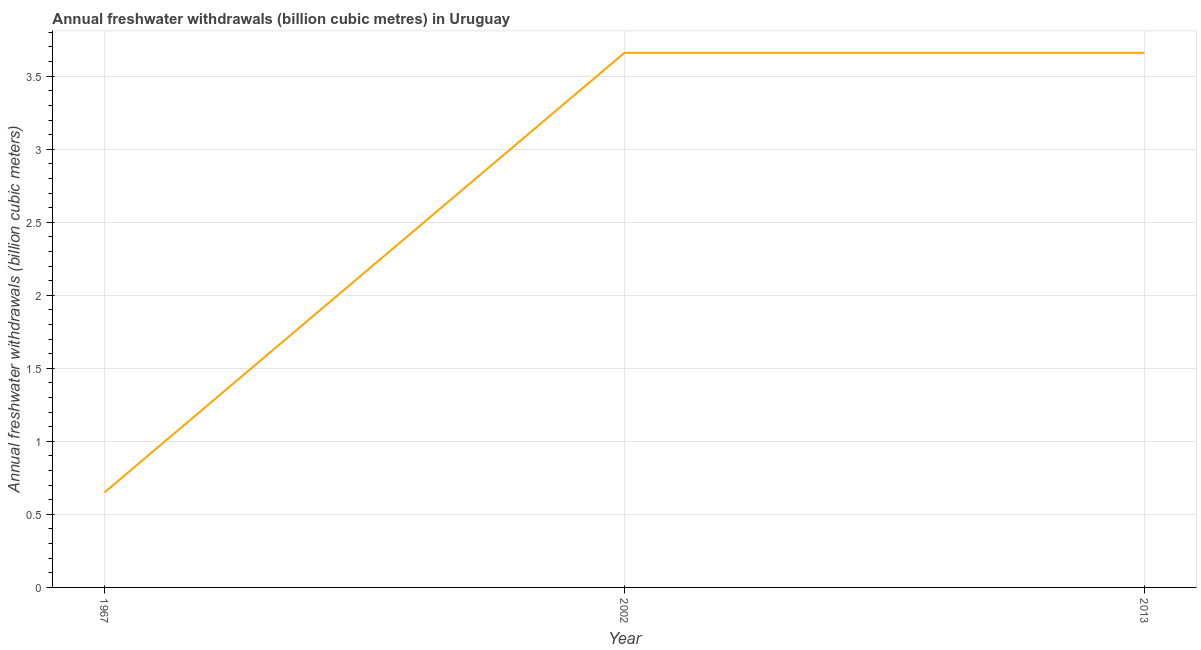What is the annual freshwater withdrawals in 2013?
Keep it short and to the point. 3.66. Across all years, what is the maximum annual freshwater withdrawals?
Your response must be concise. 3.66. Across all years, what is the minimum annual freshwater withdrawals?
Keep it short and to the point. 0.65. In which year was the annual freshwater withdrawals minimum?
Ensure brevity in your answer.  1967. What is the sum of the annual freshwater withdrawals?
Keep it short and to the point. 7.97. What is the difference between the annual freshwater withdrawals in 1967 and 2013?
Give a very brief answer. -3.01. What is the average annual freshwater withdrawals per year?
Your response must be concise. 2.66. What is the median annual freshwater withdrawals?
Provide a short and direct response. 3.66. In how many years, is the annual freshwater withdrawals greater than 1.8 billion cubic meters?
Make the answer very short. 2. What is the ratio of the annual freshwater withdrawals in 1967 to that in 2013?
Offer a very short reply. 0.18. What is the difference between the highest and the second highest annual freshwater withdrawals?
Your answer should be very brief. 0. Is the sum of the annual freshwater withdrawals in 1967 and 2013 greater than the maximum annual freshwater withdrawals across all years?
Offer a terse response. Yes. What is the difference between the highest and the lowest annual freshwater withdrawals?
Ensure brevity in your answer.  3.01. In how many years, is the annual freshwater withdrawals greater than the average annual freshwater withdrawals taken over all years?
Make the answer very short. 2. How many years are there in the graph?
Provide a short and direct response. 3. What is the difference between two consecutive major ticks on the Y-axis?
Offer a terse response. 0.5. Are the values on the major ticks of Y-axis written in scientific E-notation?
Make the answer very short. No. What is the title of the graph?
Your answer should be compact. Annual freshwater withdrawals (billion cubic metres) in Uruguay. What is the label or title of the X-axis?
Offer a very short reply. Year. What is the label or title of the Y-axis?
Give a very brief answer. Annual freshwater withdrawals (billion cubic meters). What is the Annual freshwater withdrawals (billion cubic meters) of 1967?
Make the answer very short. 0.65. What is the Annual freshwater withdrawals (billion cubic meters) of 2002?
Offer a terse response. 3.66. What is the Annual freshwater withdrawals (billion cubic meters) in 2013?
Make the answer very short. 3.66. What is the difference between the Annual freshwater withdrawals (billion cubic meters) in 1967 and 2002?
Give a very brief answer. -3.01. What is the difference between the Annual freshwater withdrawals (billion cubic meters) in 1967 and 2013?
Ensure brevity in your answer.  -3.01. What is the ratio of the Annual freshwater withdrawals (billion cubic meters) in 1967 to that in 2002?
Ensure brevity in your answer.  0.18. What is the ratio of the Annual freshwater withdrawals (billion cubic meters) in 1967 to that in 2013?
Provide a short and direct response. 0.18. What is the ratio of the Annual freshwater withdrawals (billion cubic meters) in 2002 to that in 2013?
Make the answer very short. 1. 